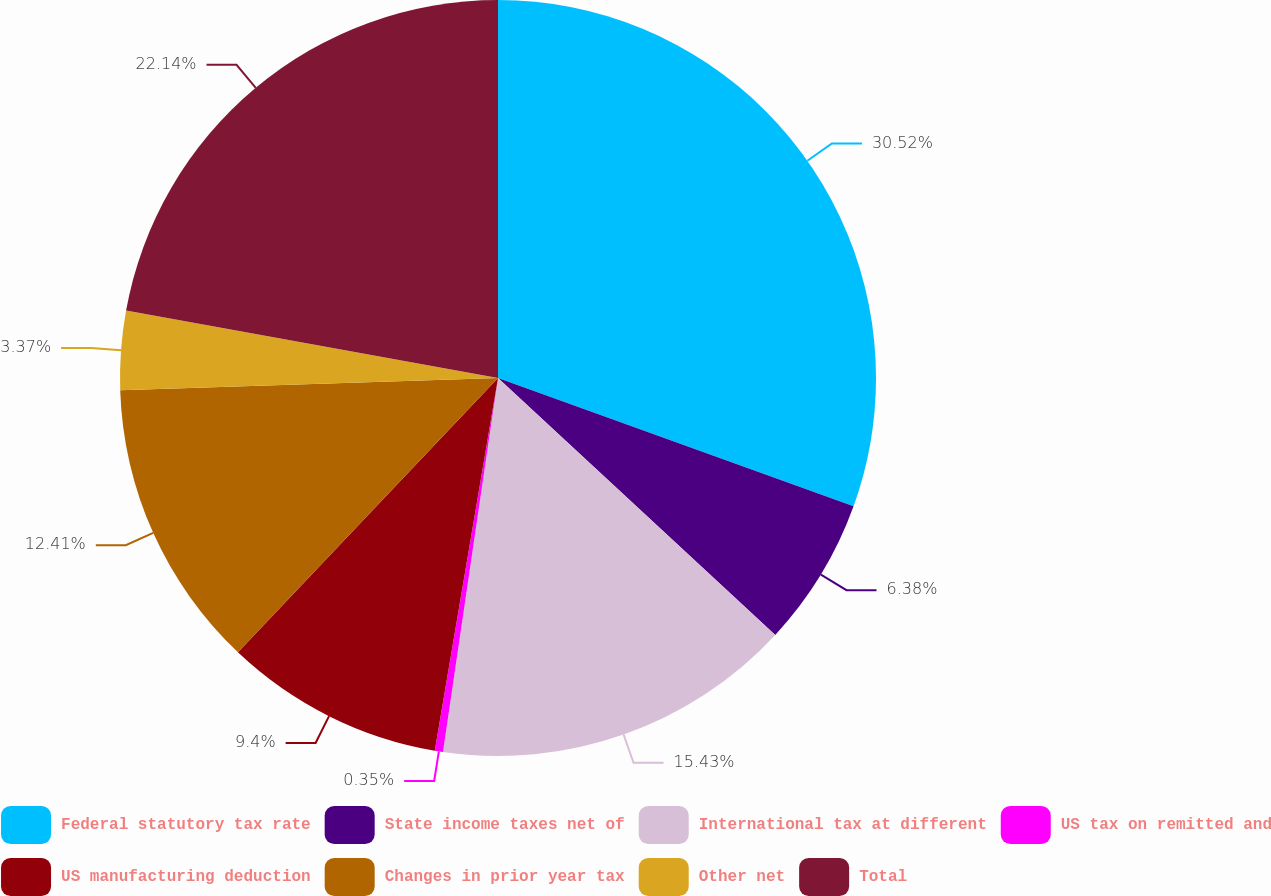<chart> <loc_0><loc_0><loc_500><loc_500><pie_chart><fcel>Federal statutory tax rate<fcel>State income taxes net of<fcel>International tax at different<fcel>US tax on remitted and<fcel>US manufacturing deduction<fcel>Changes in prior year tax<fcel>Other net<fcel>Total<nl><fcel>30.51%<fcel>6.38%<fcel>15.43%<fcel>0.35%<fcel>9.4%<fcel>12.41%<fcel>3.37%<fcel>22.14%<nl></chart> 